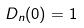<formula> <loc_0><loc_0><loc_500><loc_500>D _ { n } ( 0 ) = 1</formula> 